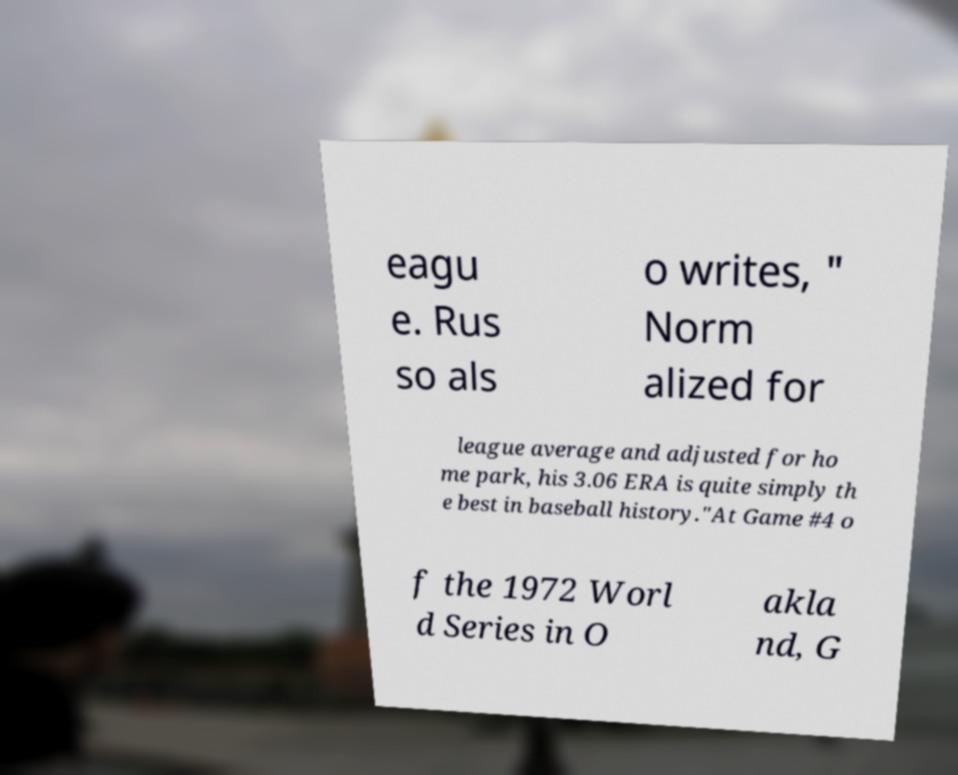What messages or text are displayed in this image? I need them in a readable, typed format. eagu e. Rus so als o writes, " Norm alized for league average and adjusted for ho me park, his 3.06 ERA is quite simply th e best in baseball history."At Game #4 o f the 1972 Worl d Series in O akla nd, G 